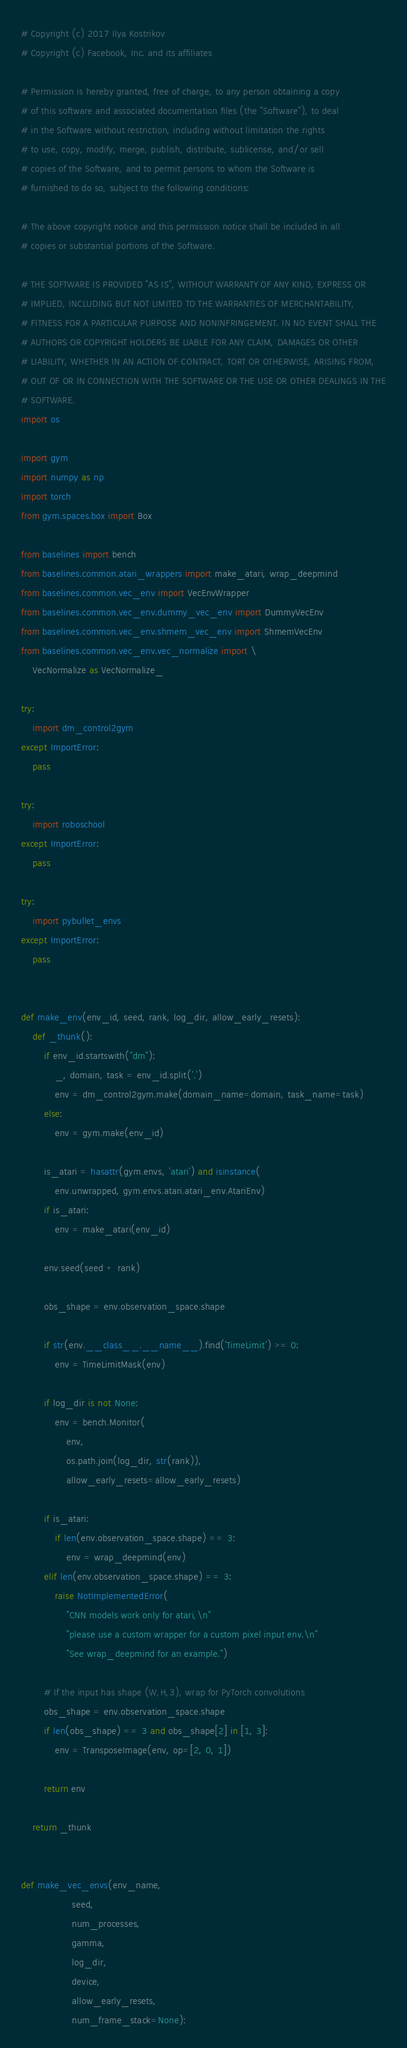Convert code to text. <code><loc_0><loc_0><loc_500><loc_500><_Python_># Copyright (c) 2017 Ilya Kostrikov
# Copyright (c) Facebook, Inc. and its affiliates

# Permission is hereby granted, free of charge, to any person obtaining a copy
# of this software and associated documentation files (the "Software"), to deal
# in the Software without restriction, including without limitation the rights
# to use, copy, modify, merge, publish, distribute, sublicense, and/or sell
# copies of the Software, and to permit persons to whom the Software is
# furnished to do so, subject to the following conditions:

# The above copyright notice and this permission notice shall be included in all
# copies or substantial portions of the Software.

# THE SOFTWARE IS PROVIDED "AS IS", WITHOUT WARRANTY OF ANY KIND, EXPRESS OR
# IMPLIED, INCLUDING BUT NOT LIMITED TO THE WARRANTIES OF MERCHANTABILITY,
# FITNESS FOR A PARTICULAR PURPOSE AND NONINFRINGEMENT. IN NO EVENT SHALL THE
# AUTHORS OR COPYRIGHT HOLDERS BE LIABLE FOR ANY CLAIM, DAMAGES OR OTHER
# LIABILITY, WHETHER IN AN ACTION OF CONTRACT, TORT OR OTHERWISE, ARISING FROM,
# OUT OF OR IN CONNECTION WITH THE SOFTWARE OR THE USE OR OTHER DEALINGS IN THE
# SOFTWARE.
import os

import gym
import numpy as np
import torch
from gym.spaces.box import Box

from baselines import bench
from baselines.common.atari_wrappers import make_atari, wrap_deepmind
from baselines.common.vec_env import VecEnvWrapper
from baselines.common.vec_env.dummy_vec_env import DummyVecEnv
from baselines.common.vec_env.shmem_vec_env import ShmemVecEnv
from baselines.common.vec_env.vec_normalize import \
    VecNormalize as VecNormalize_

try:
    import dm_control2gym
except ImportError:
    pass

try:
    import roboschool
except ImportError:
    pass

try:
    import pybullet_envs
except ImportError:
    pass


def make_env(env_id, seed, rank, log_dir, allow_early_resets):
    def _thunk():
        if env_id.startswith("dm"):
            _, domain, task = env_id.split('.')
            env = dm_control2gym.make(domain_name=domain, task_name=task)
        else:
            env = gym.make(env_id)

        is_atari = hasattr(gym.envs, 'atari') and isinstance(
            env.unwrapped, gym.envs.atari.atari_env.AtariEnv)
        if is_atari:
            env = make_atari(env_id)

        env.seed(seed + rank)

        obs_shape = env.observation_space.shape

        if str(env.__class__.__name__).find('TimeLimit') >= 0:
            env = TimeLimitMask(env)

        if log_dir is not None:
            env = bench.Monitor(
                env,
                os.path.join(log_dir, str(rank)),
                allow_early_resets=allow_early_resets)

        if is_atari:
            if len(env.observation_space.shape) == 3:
                env = wrap_deepmind(env)
        elif len(env.observation_space.shape) == 3:
            raise NotImplementedError(
                "CNN models work only for atari,\n"
                "please use a custom wrapper for a custom pixel input env.\n"
                "See wrap_deepmind for an example.")

        # If the input has shape (W,H,3), wrap for PyTorch convolutions
        obs_shape = env.observation_space.shape
        if len(obs_shape) == 3 and obs_shape[2] in [1, 3]:
            env = TransposeImage(env, op=[2, 0, 1])

        return env

    return _thunk


def make_vec_envs(env_name,
                  seed,
                  num_processes,
                  gamma,
                  log_dir,
                  device,
                  allow_early_resets,
                  num_frame_stack=None):</code> 